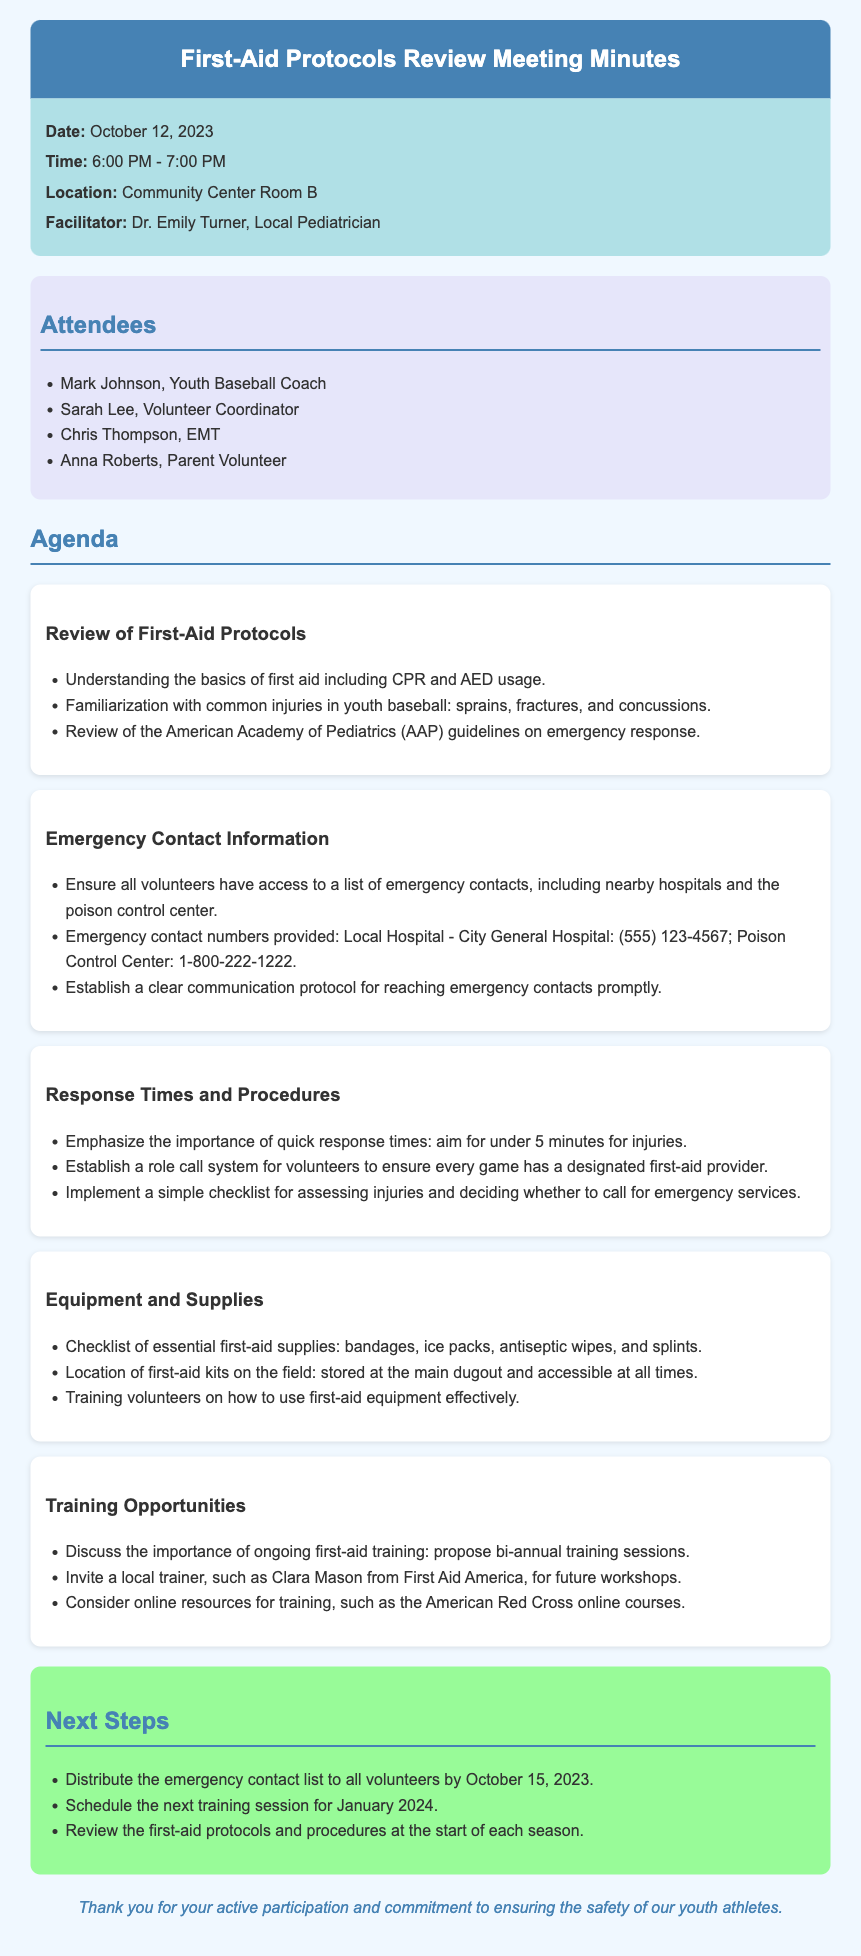What is the date of the meeting? The date of the meeting is explicitly mentioned in the "meeting-info" section of the document.
Answer: October 12, 2023 Who facilitated the meeting? The facilitator's name is provided in the "meeting-info" section, highlighting their role.
Answer: Dr. Emily Turner What are the emergency contact numbers provided? The document includes specific numbers in the "Emergency Contact Information" section for quick reference.
Answer: City General Hospital: (555) 123-4567; Poison Control Center: 1-800-222-1222 What is the target response time for injuries? The document states a goal for response times in the "Response Times and Procedures" section.
Answer: Under 5 minutes What should be established to ensure every game has a first-aid provider? The text suggests a systematic approach in the "Response Times and Procedures" agenda item.
Answer: Role call system What training opportunity was proposed at the meeting? The agenda includes a discussion about ongoing training in the "Training Opportunities" section.
Answer: Bi-annual training sessions What is the location of the first-aid kits on the field? The document specifies the locations of the first-aid kits in the "Equipment and Supplies" section.
Answer: Main dugout By when should the emergency contact list be distributed? This information is detailed in the "Next Steps" section to provide clear timelines for actions.
Answer: October 15, 2023 What is the name of the local trainer invited for future workshops? The document explicitly mentions the trainer's name in the "Training Opportunities" section.
Answer: Clara Mason 